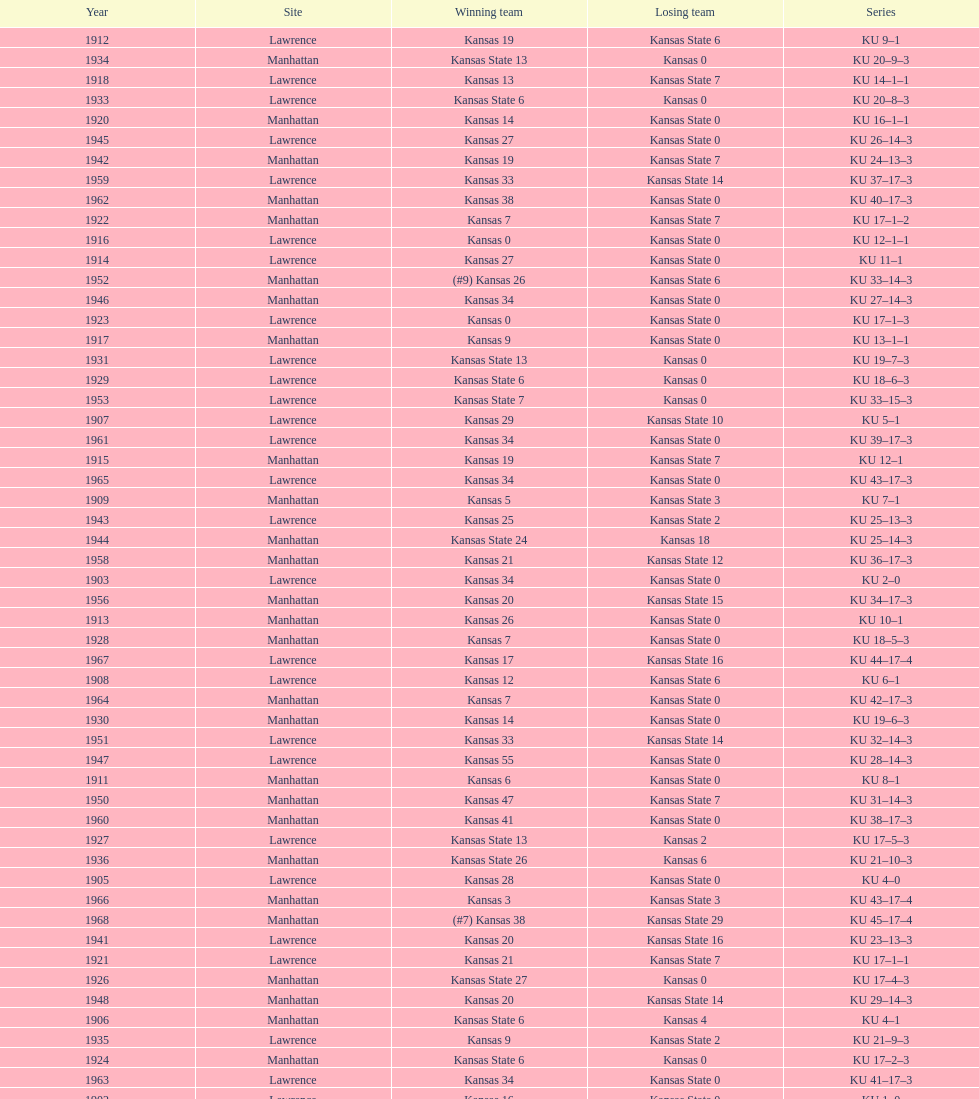Before 1950 what was the most points kansas scored? 55. 